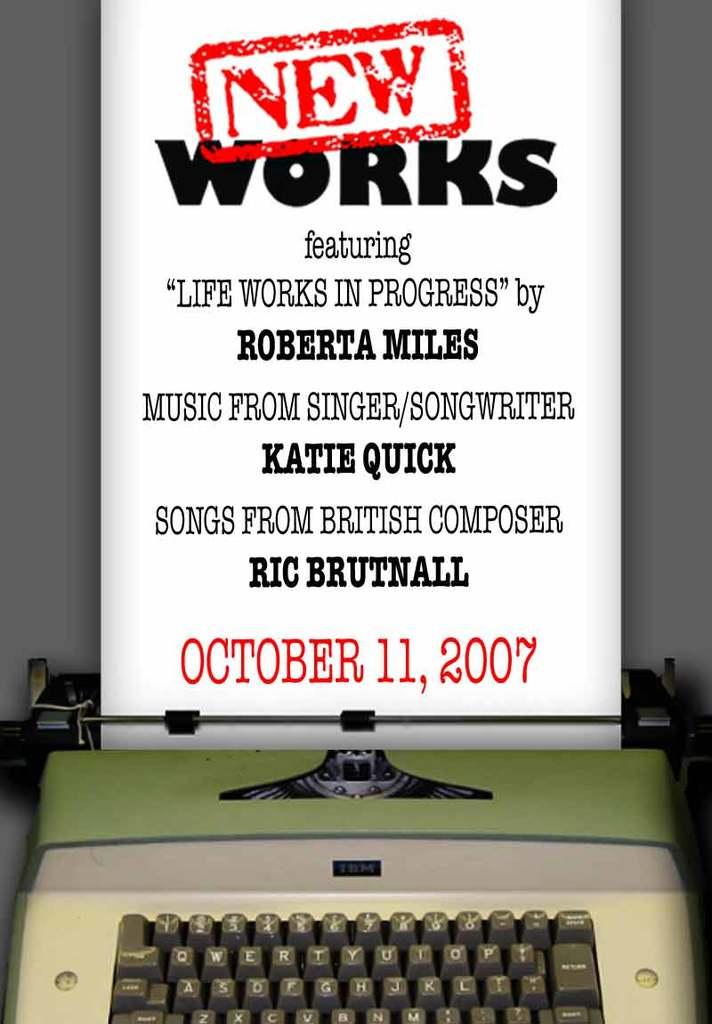What month is shown on the typewriter page?
Offer a very short reply. October. What year is written in red?
Your answer should be very brief. 2007. 